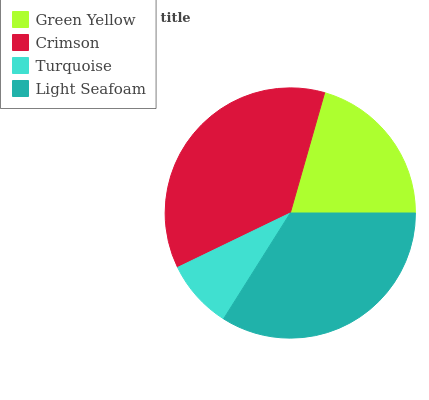Is Turquoise the minimum?
Answer yes or no. Yes. Is Crimson the maximum?
Answer yes or no. Yes. Is Crimson the minimum?
Answer yes or no. No. Is Turquoise the maximum?
Answer yes or no. No. Is Crimson greater than Turquoise?
Answer yes or no. Yes. Is Turquoise less than Crimson?
Answer yes or no. Yes. Is Turquoise greater than Crimson?
Answer yes or no. No. Is Crimson less than Turquoise?
Answer yes or no. No. Is Light Seafoam the high median?
Answer yes or no. Yes. Is Green Yellow the low median?
Answer yes or no. Yes. Is Green Yellow the high median?
Answer yes or no. No. Is Turquoise the low median?
Answer yes or no. No. 